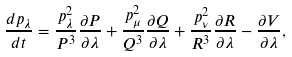<formula> <loc_0><loc_0><loc_500><loc_500>\frac { d p _ { \lambda } } { d t } = \frac { p _ { \lambda } ^ { 2 } } { P ^ { 3 } } \frac { \partial P } { \partial \lambda } + \frac { p _ { \mu } ^ { 2 } } { Q ^ { 3 } } \frac { \partial Q } { \partial \lambda } + \frac { p _ { \nu } ^ { 2 } } { R ^ { 3 } } \frac { \partial R } { \partial \lambda } - \frac { \partial V } { \partial \lambda } ,</formula> 